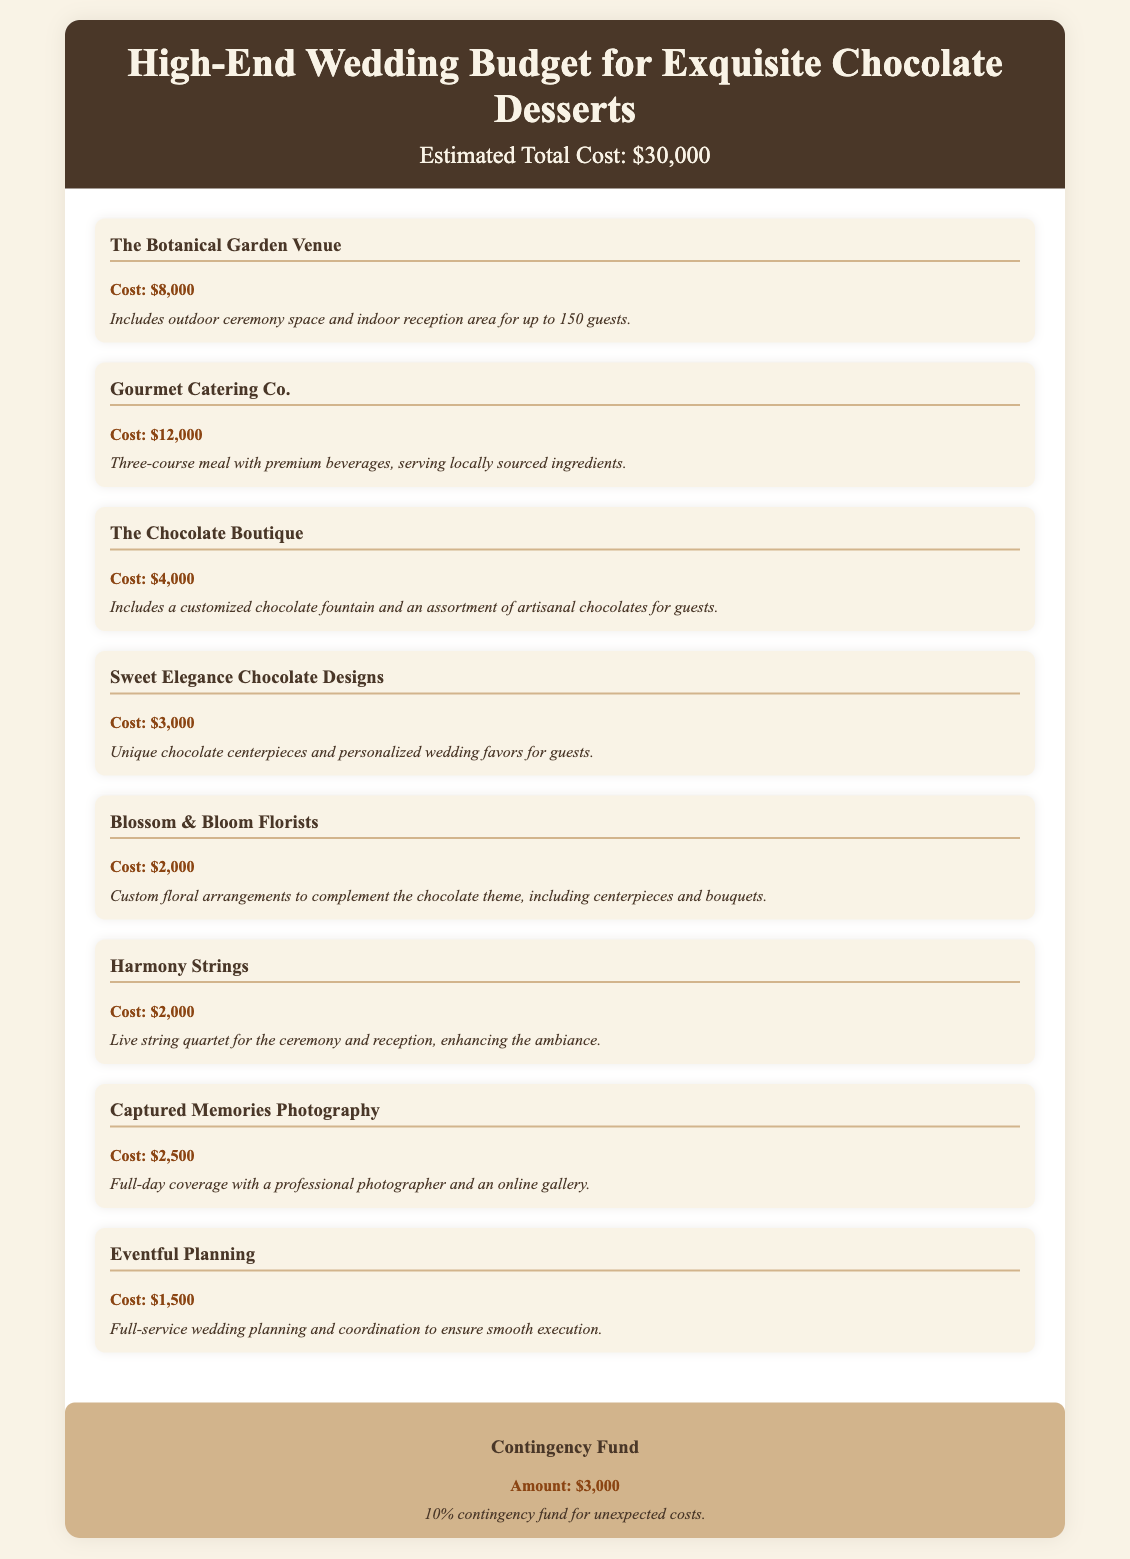What is the total estimated cost of the wedding? The total estimated cost is stated at the beginning of the document as $30,000.
Answer: $30,000 What is the cost of the venue? The cost for The Botanical Garden Venue is specified in the document as $8,000.
Answer: $8,000 How much is allocated for gourmet catering? The document mentions that Gourmet Catering Co. costs $12,000 for the catering services.
Answer: $12,000 What is included in the budget for chocolate arrangements? The budget for chocolate arrangements includes costs for The Chocolate Boutique and Sweet Elegance Chocolate Designs.
Answer: The Chocolate Boutique and Sweet Elegance Chocolate Designs How much is set aside for the contingency fund? The document clearly states a contingency fund of $3,000 for unexpected costs.
Answer: $3,000 How much does Captured Memories Photography charge? The document lists the charge for Captured Memories Photography as $2,500 for full-day coverage.
Answer: $2,500 What services does Eventful Planning provide? The document indicates that Eventful Planning offers full-service wedding planning and coordination.
Answer: Full-service wedding planning and coordination Which vendor provides floral arrangements? Blossom & Bloom Florists is the vendor mentioned in the budget for floral arrangements.
Answer: Blossom & Bloom Florists What is the total cost of chocolate-related services? The combined cost of The Chocolate Boutique and Sweet Elegance Chocolate Designs for chocolate services is calculated as $4,000 + $3,000.
Answer: $7,000 